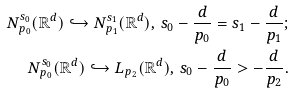Convert formula to latex. <formula><loc_0><loc_0><loc_500><loc_500>N ^ { s _ { 0 } } _ { p _ { 0 } } ( \mathbb { R } ^ { d } ) \hookrightarrow N ^ { s _ { 1 } } _ { p _ { 1 } } ( \mathbb { R } ^ { d } ) , \, s _ { 0 } - \frac { d } { p _ { 0 } } = s _ { 1 } - \frac { d } { p _ { 1 } } ; \\ N ^ { s _ { 0 } } _ { p _ { 0 } } ( \mathbb { R } ^ { d } ) \hookrightarrow L _ { p _ { 2 } } ( \mathbb { R } ^ { d } ) , \, s _ { 0 } - \frac { d } { p _ { 0 } } > - \frac { d } { p _ { 2 } } .</formula> 